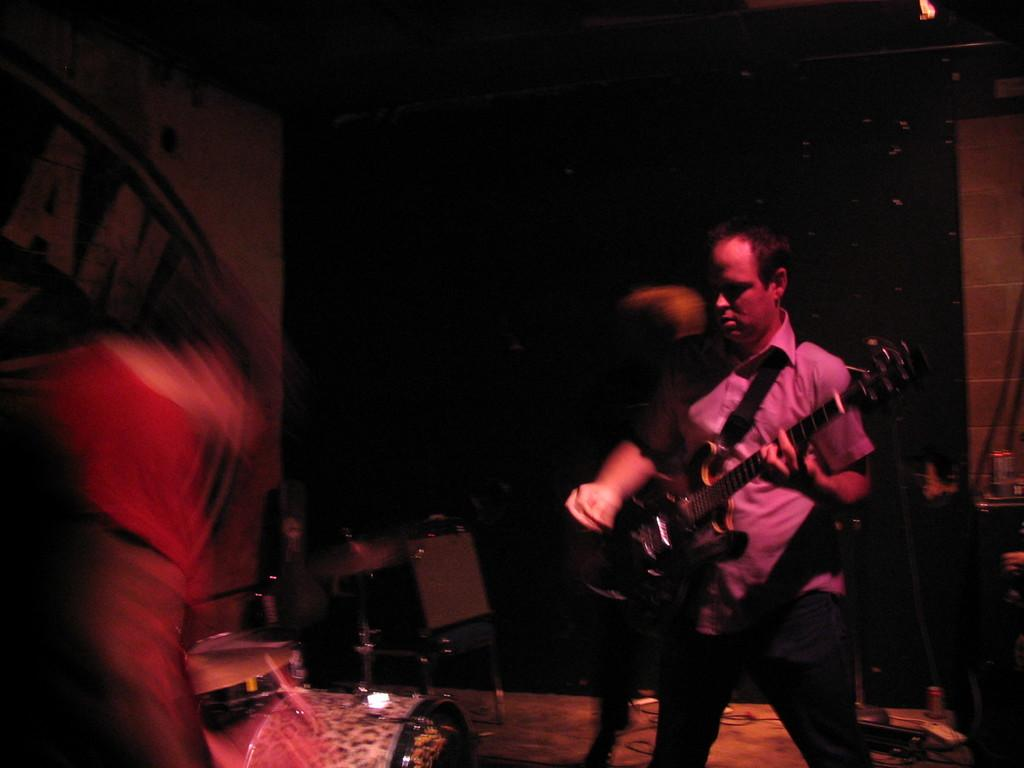What is the main subject of the image? There is a person in the image. What is the person doing in the image? The person is standing and holding a guitar. What is the color of the background in the image? The background in the image is black. What type of clothing is the person wearing? The person is wearing a shirt and a pant. What type of bucket can be seen in the image? There is no bucket present in the image. How many passengers are visible in the image? There are no passengers visible in the image, as it only features a person holding a guitar. 